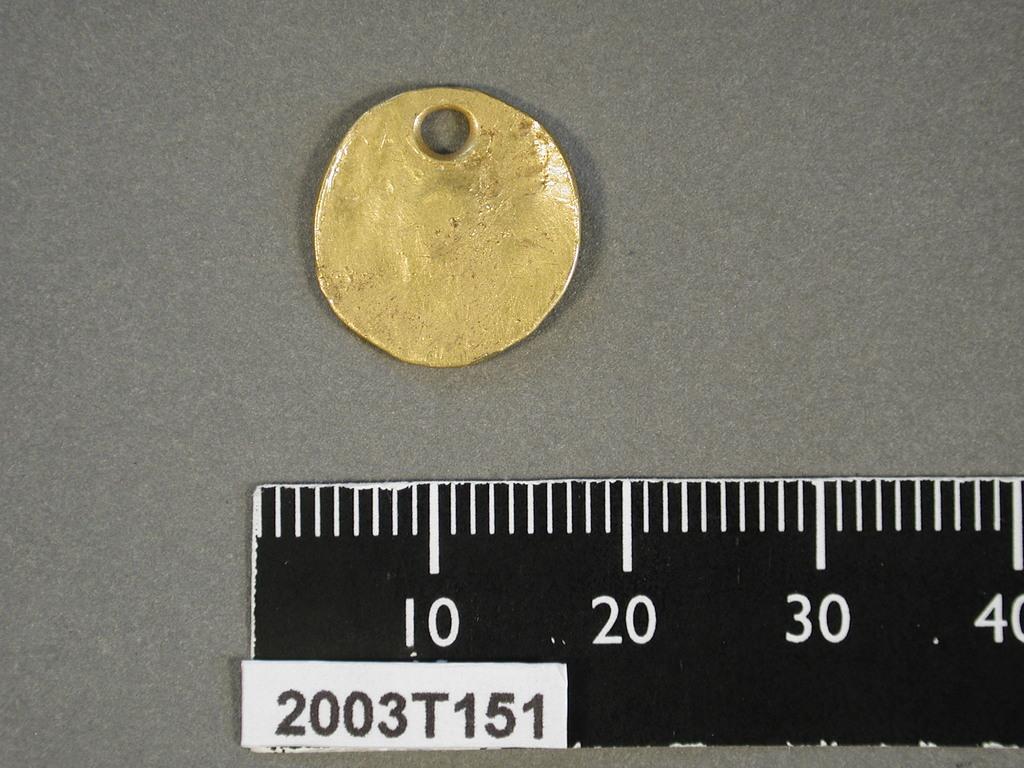What is the serial number?
Ensure brevity in your answer.  2003t151. What is the first measurement on the ruler?
Your answer should be very brief. 10. 